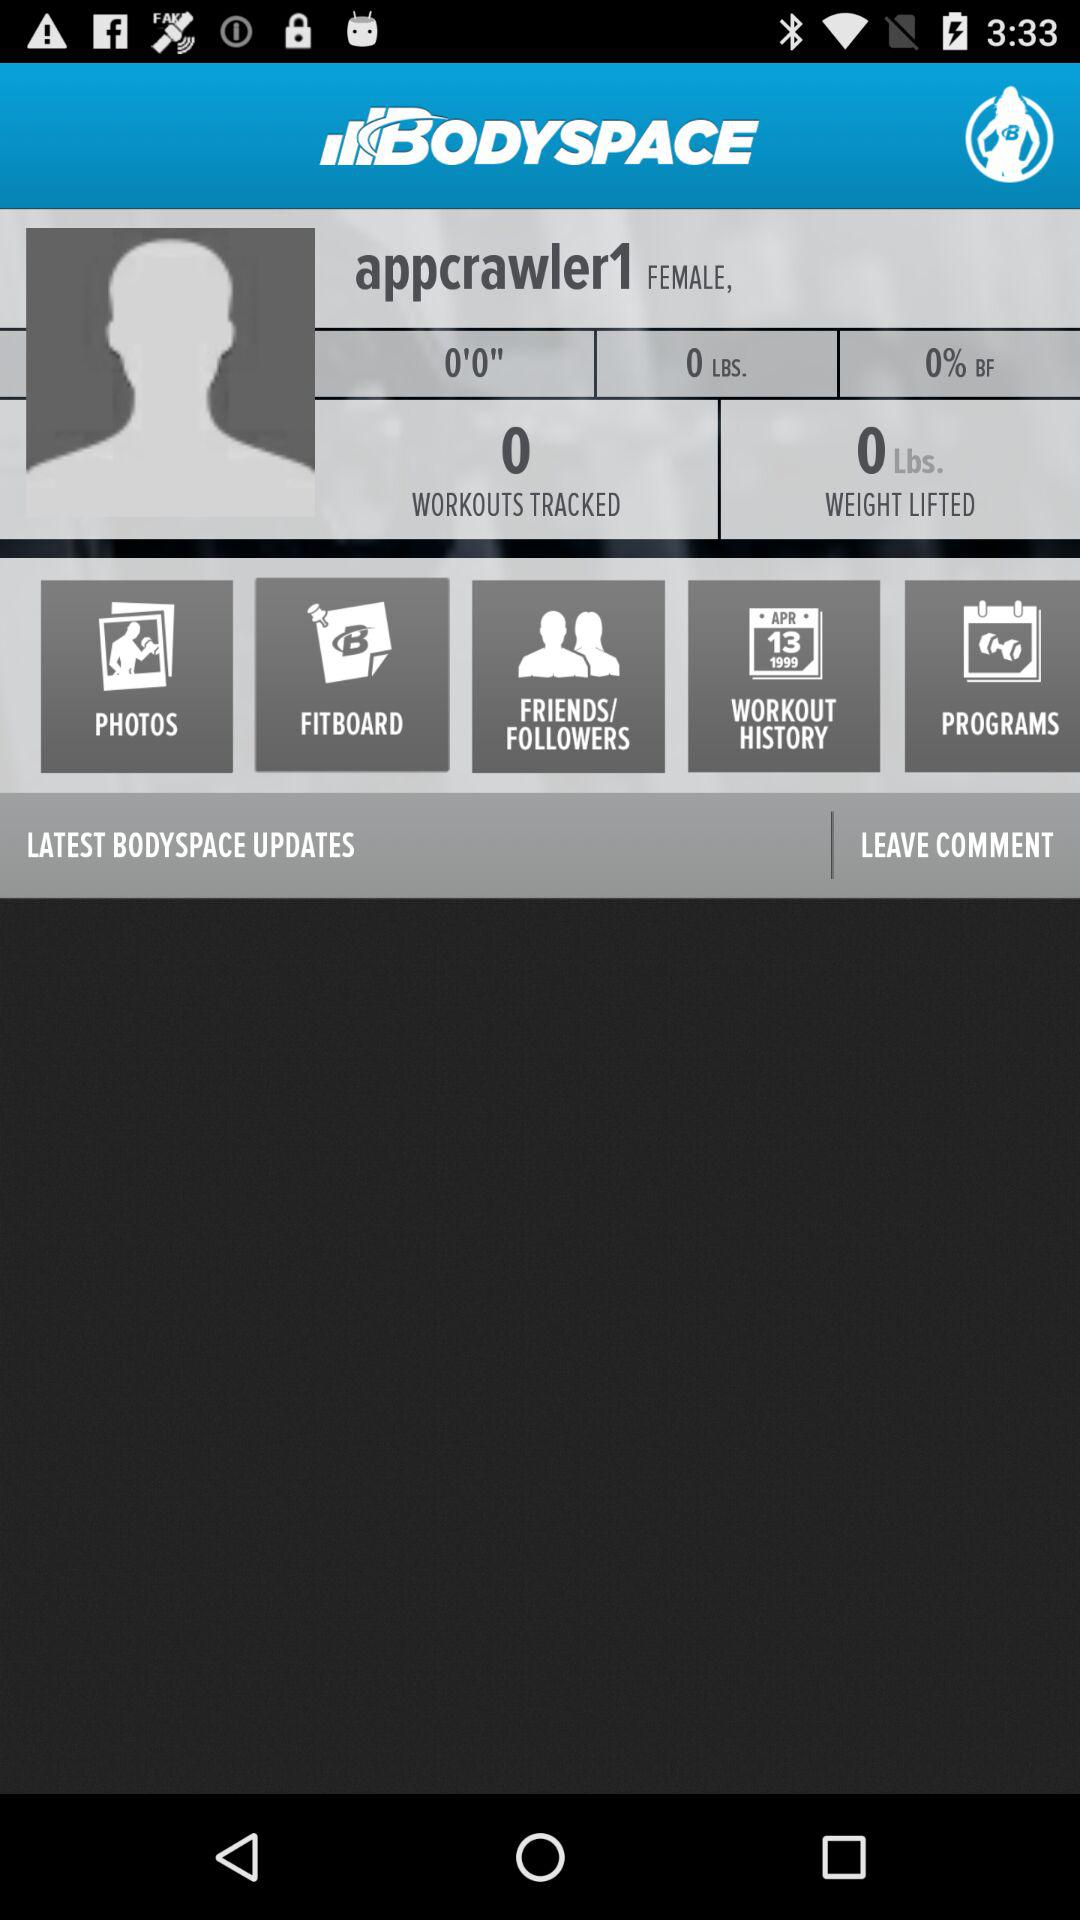How much weight is lifted? The lifted weight is 0 lbs. 